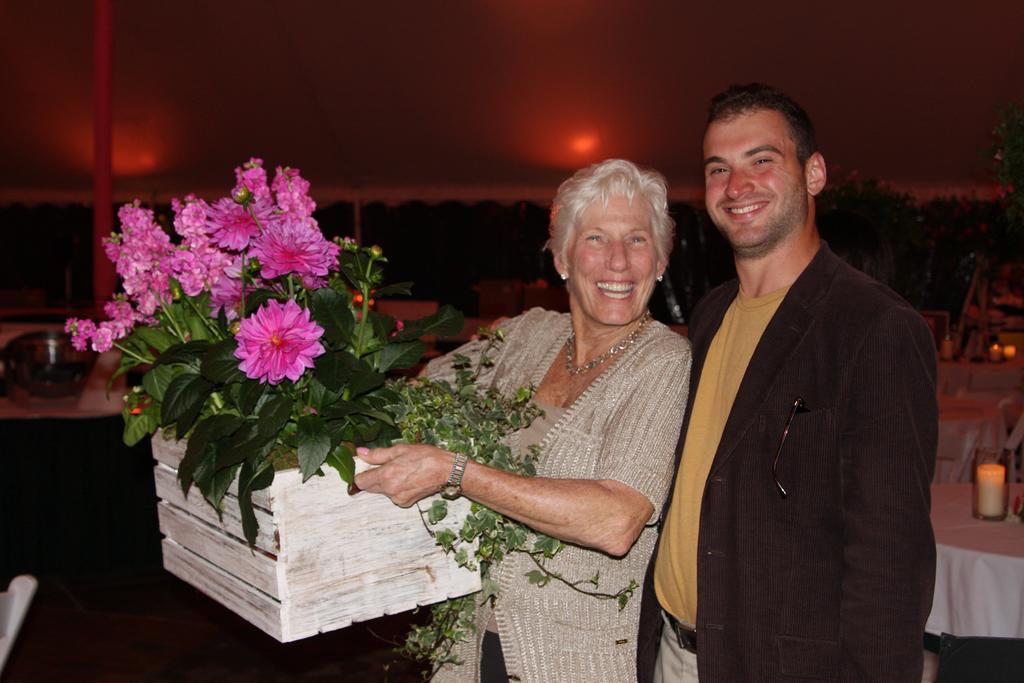Can you describe this image briefly? This is the picture of a place where we have a guy and a lady who is holding the plant and behind there is a table on which there are some things placed. 